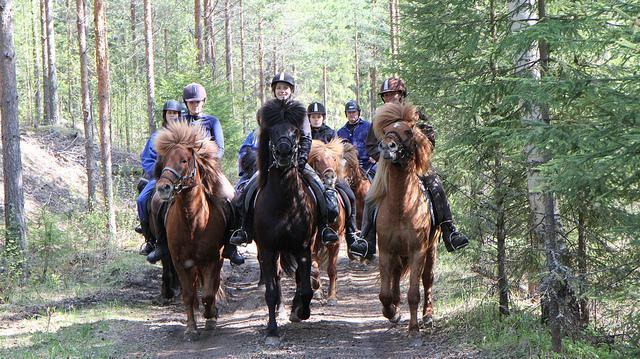What is unusually long here?
Make your selection and explain in format: 'Answer: answer
Rationale: rationale.'
Options: Manes, roads, helmets, hooves. Answer: manes.
Rationale: The manes are long. 